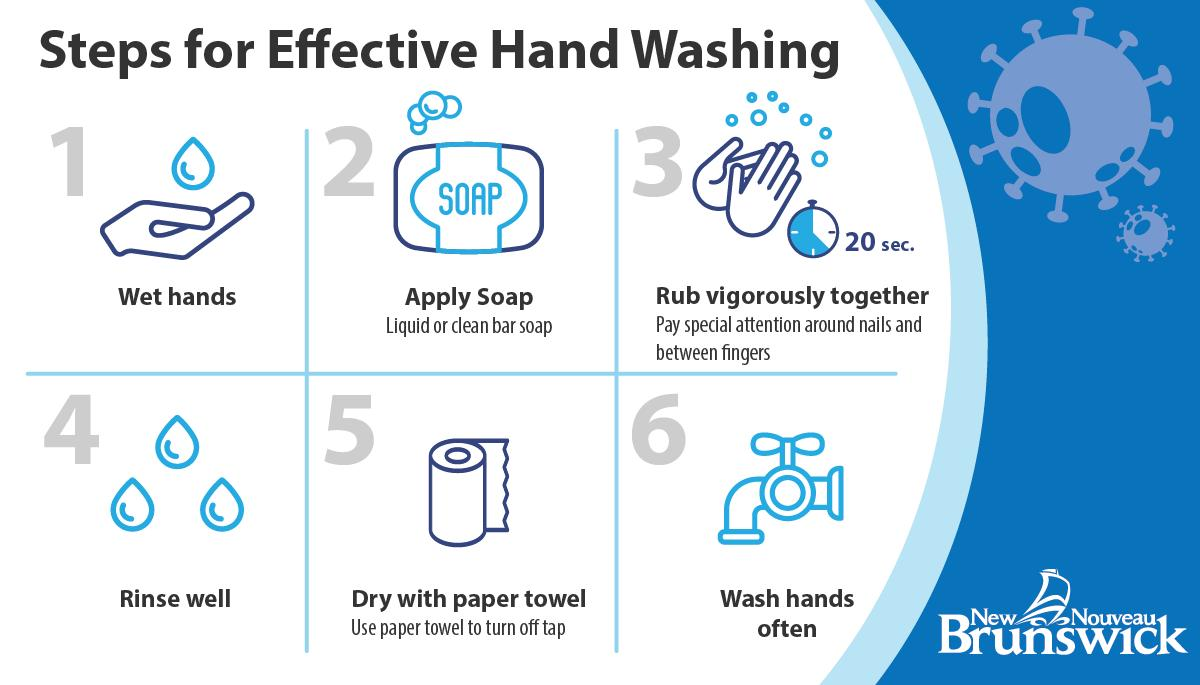Mention a couple of crucial points in this snapshot. After rinsing your hands with soap and water, it is recommended to dry them with a clean paper towel to remove excess moisture and prevent the spread of bacteria. After applying soap, it is important to rub it vigorously together to ensure that it is evenly distributed and has been properly absorbed by the skin. The image of a tap appears a total of 1 time in the range 1 to... For a duration of 20 seconds, it is expected to rub your hands with soap. The first two steps in the effects of handwashing are to wet the hands with water and apply soap. 